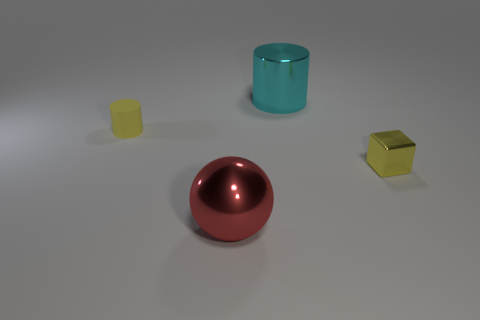There is another thing that is the same shape as the tiny rubber object; what is it made of?
Make the answer very short. Metal. Does the big thing that is behind the yellow matte cylinder have the same shape as the tiny thing to the left of the large cyan cylinder?
Ensure brevity in your answer.  Yes. Is the number of red things greater than the number of tiny purple spheres?
Your response must be concise. Yes. How big is the ball?
Give a very brief answer. Large. What number of other things are the same color as the large metallic sphere?
Offer a terse response. 0. Do the yellow object that is behind the yellow block and the cyan object have the same material?
Provide a short and direct response. No. Are there fewer yellow things that are on the left side of the big shiny cylinder than tiny yellow objects behind the red object?
Your response must be concise. Yes. What number of other things are there of the same material as the small yellow cylinder
Your answer should be compact. 0. There is a red object that is the same size as the shiny cylinder; what material is it?
Offer a very short reply. Metal. Are there fewer cyan metal cylinders that are in front of the small cylinder than large red spheres?
Keep it short and to the point. Yes. 